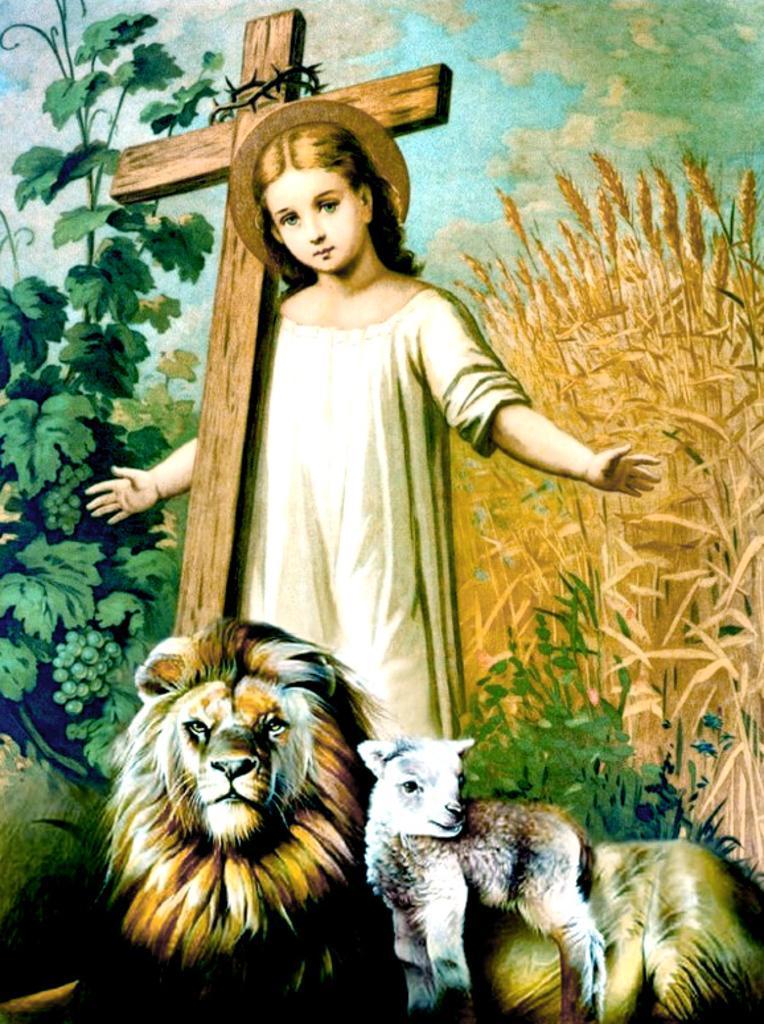In one or two sentences, can you explain what this image depicts? There is a person in white color dress standing near a wooden cross. Which is having the crown of barbed wire, near a lion, a sheep, plants and fields which are having seeds. In the background, there are clouds in the blue sky. 